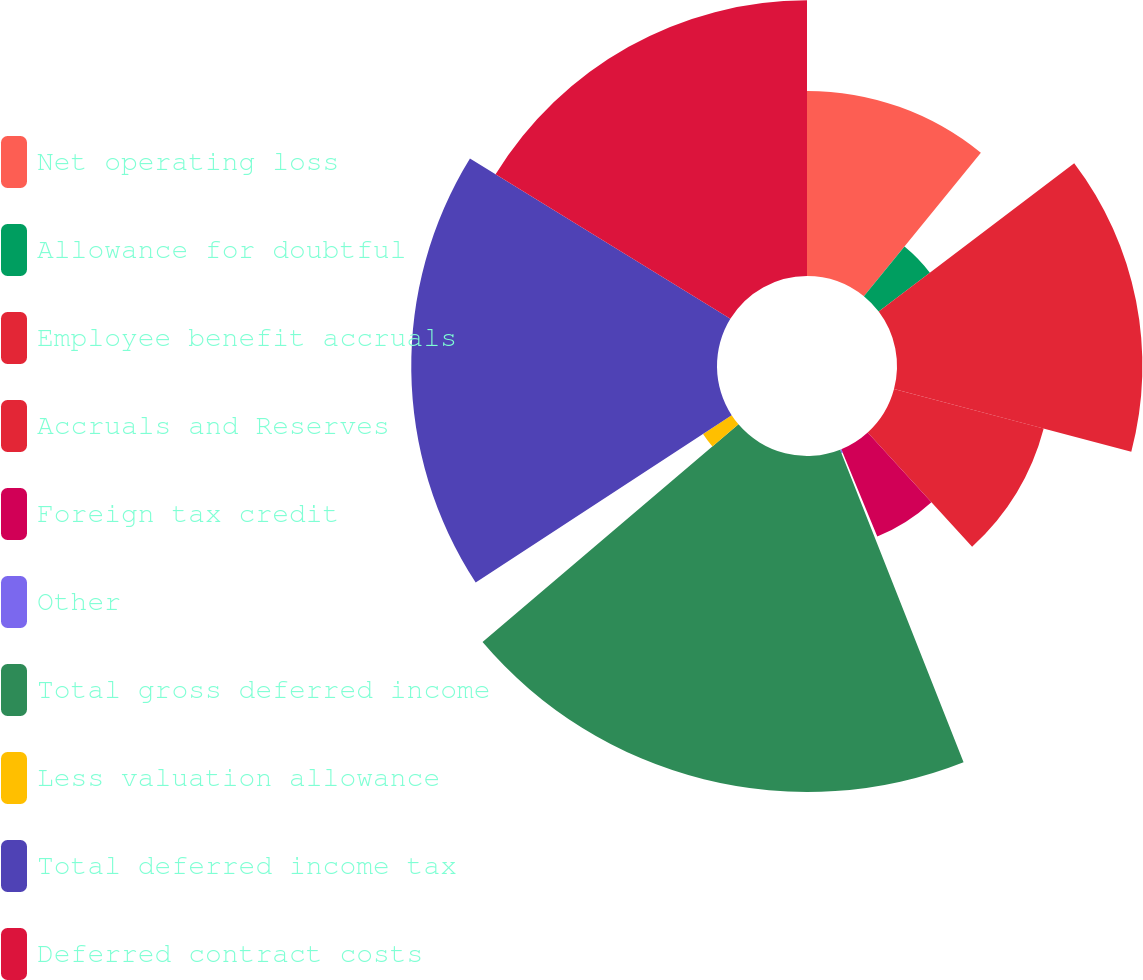<chart> <loc_0><loc_0><loc_500><loc_500><pie_chart><fcel>Net operating loss<fcel>Allowance for doubtful<fcel>Employee benefit accruals<fcel>Accruals and Reserves<fcel>Foreign tax credit<fcel>Other<fcel>Total gross deferred income<fcel>Less valuation allowance<fcel>Total deferred income tax<fcel>Deferred contract costs<nl><fcel>10.89%<fcel>3.78%<fcel>14.44%<fcel>9.11%<fcel>5.56%<fcel>0.23%<fcel>19.77%<fcel>2.01%<fcel>17.99%<fcel>16.22%<nl></chart> 